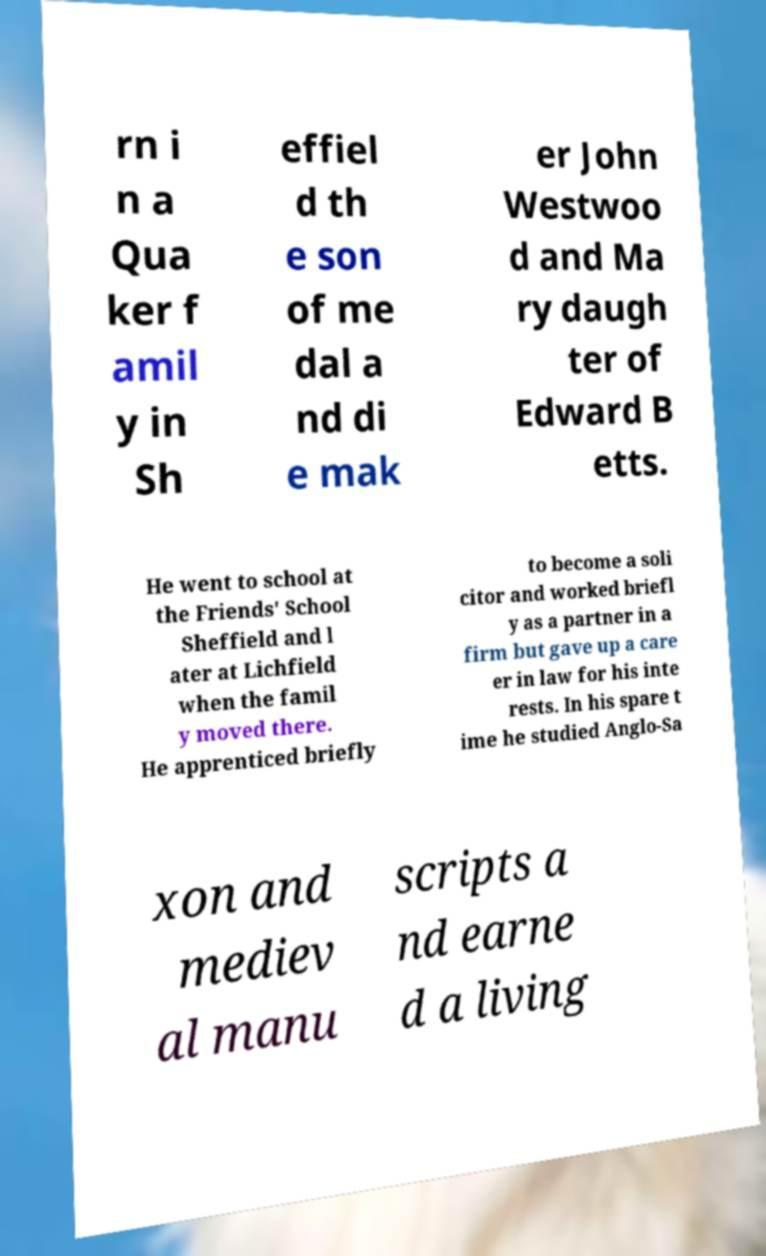I need the written content from this picture converted into text. Can you do that? rn i n a Qua ker f amil y in Sh effiel d th e son of me dal a nd di e mak er John Westwoo d and Ma ry daugh ter of Edward B etts. He went to school at the Friends' School Sheffield and l ater at Lichfield when the famil y moved there. He apprenticed briefly to become a soli citor and worked briefl y as a partner in a firm but gave up a care er in law for his inte rests. In his spare t ime he studied Anglo-Sa xon and mediev al manu scripts a nd earne d a living 